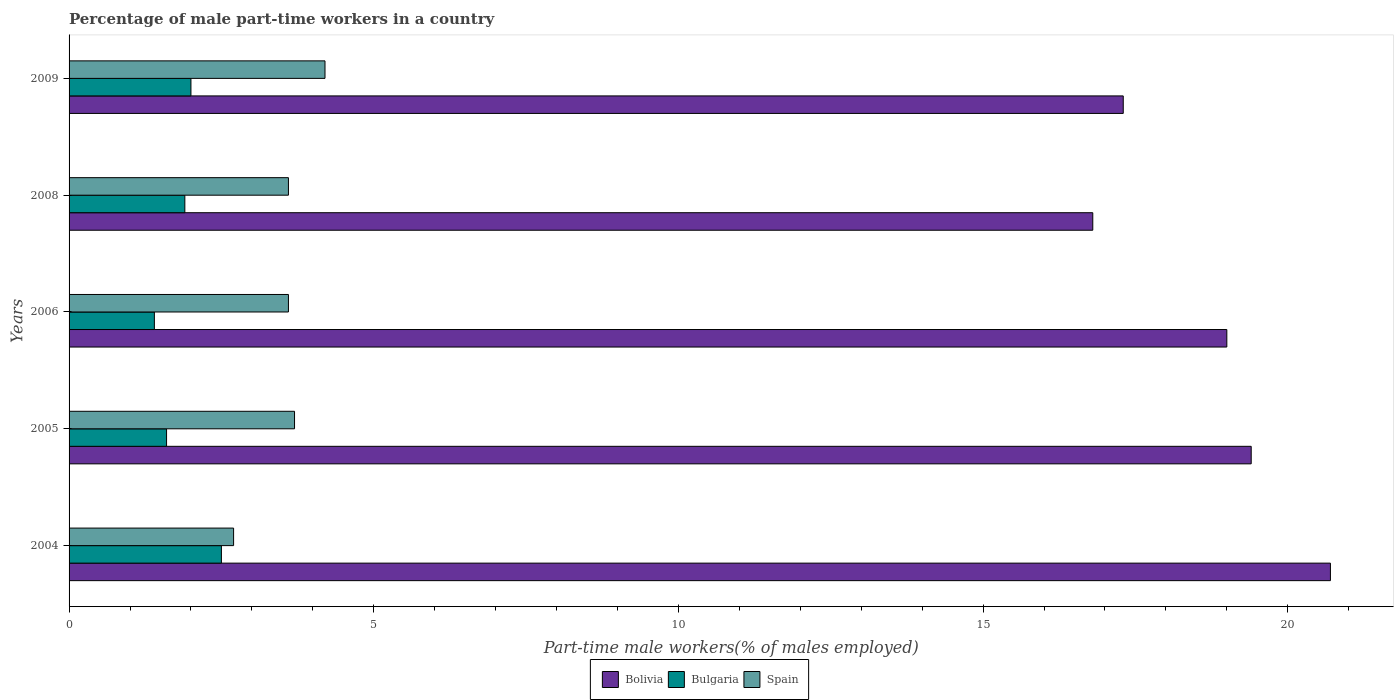How many different coloured bars are there?
Ensure brevity in your answer.  3. Are the number of bars on each tick of the Y-axis equal?
Provide a succinct answer. Yes. How many bars are there on the 1st tick from the bottom?
Your answer should be very brief. 3. In how many cases, is the number of bars for a given year not equal to the number of legend labels?
Ensure brevity in your answer.  0. What is the percentage of male part-time workers in Bulgaria in 2005?
Your answer should be very brief. 1.6. Across all years, what is the maximum percentage of male part-time workers in Spain?
Your response must be concise. 4.2. Across all years, what is the minimum percentage of male part-time workers in Spain?
Provide a short and direct response. 2.7. What is the total percentage of male part-time workers in Bolivia in the graph?
Ensure brevity in your answer.  93.2. What is the difference between the percentage of male part-time workers in Bulgaria in 2006 and that in 2009?
Give a very brief answer. -0.6. What is the difference between the percentage of male part-time workers in Bulgaria in 2006 and the percentage of male part-time workers in Spain in 2009?
Ensure brevity in your answer.  -2.8. What is the average percentage of male part-time workers in Bulgaria per year?
Offer a very short reply. 1.88. In the year 2009, what is the difference between the percentage of male part-time workers in Bolivia and percentage of male part-time workers in Spain?
Make the answer very short. 13.1. What is the ratio of the percentage of male part-time workers in Bolivia in 2004 to that in 2006?
Your answer should be compact. 1.09. Is the percentage of male part-time workers in Bolivia in 2006 less than that in 2009?
Offer a terse response. No. What is the difference between the highest and the lowest percentage of male part-time workers in Bulgaria?
Provide a short and direct response. 1.1. Are all the bars in the graph horizontal?
Offer a very short reply. Yes. How many legend labels are there?
Your response must be concise. 3. How are the legend labels stacked?
Provide a succinct answer. Horizontal. What is the title of the graph?
Provide a short and direct response. Percentage of male part-time workers in a country. What is the label or title of the X-axis?
Ensure brevity in your answer.  Part-time male workers(% of males employed). What is the Part-time male workers(% of males employed) of Bolivia in 2004?
Keep it short and to the point. 20.7. What is the Part-time male workers(% of males employed) in Spain in 2004?
Offer a very short reply. 2.7. What is the Part-time male workers(% of males employed) in Bolivia in 2005?
Your answer should be very brief. 19.4. What is the Part-time male workers(% of males employed) of Bulgaria in 2005?
Make the answer very short. 1.6. What is the Part-time male workers(% of males employed) in Spain in 2005?
Offer a very short reply. 3.7. What is the Part-time male workers(% of males employed) of Bulgaria in 2006?
Your answer should be compact. 1.4. What is the Part-time male workers(% of males employed) of Spain in 2006?
Make the answer very short. 3.6. What is the Part-time male workers(% of males employed) of Bolivia in 2008?
Give a very brief answer. 16.8. What is the Part-time male workers(% of males employed) of Bulgaria in 2008?
Your response must be concise. 1.9. What is the Part-time male workers(% of males employed) in Spain in 2008?
Your answer should be compact. 3.6. What is the Part-time male workers(% of males employed) of Bolivia in 2009?
Your answer should be compact. 17.3. What is the Part-time male workers(% of males employed) in Bulgaria in 2009?
Your answer should be very brief. 2. What is the Part-time male workers(% of males employed) of Spain in 2009?
Keep it short and to the point. 4.2. Across all years, what is the maximum Part-time male workers(% of males employed) of Bolivia?
Provide a short and direct response. 20.7. Across all years, what is the maximum Part-time male workers(% of males employed) in Bulgaria?
Offer a very short reply. 2.5. Across all years, what is the maximum Part-time male workers(% of males employed) of Spain?
Keep it short and to the point. 4.2. Across all years, what is the minimum Part-time male workers(% of males employed) in Bolivia?
Ensure brevity in your answer.  16.8. Across all years, what is the minimum Part-time male workers(% of males employed) of Bulgaria?
Provide a short and direct response. 1.4. Across all years, what is the minimum Part-time male workers(% of males employed) in Spain?
Make the answer very short. 2.7. What is the total Part-time male workers(% of males employed) of Bolivia in the graph?
Your answer should be very brief. 93.2. What is the total Part-time male workers(% of males employed) in Bulgaria in the graph?
Your answer should be compact. 9.4. What is the difference between the Part-time male workers(% of males employed) in Bolivia in 2004 and that in 2005?
Your answer should be very brief. 1.3. What is the difference between the Part-time male workers(% of males employed) of Bolivia in 2004 and that in 2006?
Make the answer very short. 1.7. What is the difference between the Part-time male workers(% of males employed) in Bulgaria in 2004 and that in 2006?
Ensure brevity in your answer.  1.1. What is the difference between the Part-time male workers(% of males employed) of Spain in 2004 and that in 2006?
Your answer should be very brief. -0.9. What is the difference between the Part-time male workers(% of males employed) in Spain in 2004 and that in 2008?
Ensure brevity in your answer.  -0.9. What is the difference between the Part-time male workers(% of males employed) of Bolivia in 2004 and that in 2009?
Your response must be concise. 3.4. What is the difference between the Part-time male workers(% of males employed) of Bulgaria in 2004 and that in 2009?
Your answer should be very brief. 0.5. What is the difference between the Part-time male workers(% of males employed) of Spain in 2004 and that in 2009?
Your answer should be very brief. -1.5. What is the difference between the Part-time male workers(% of males employed) in Bulgaria in 2005 and that in 2006?
Provide a succinct answer. 0.2. What is the difference between the Part-time male workers(% of males employed) in Spain in 2005 and that in 2008?
Ensure brevity in your answer.  0.1. What is the difference between the Part-time male workers(% of males employed) of Bolivia in 2006 and that in 2009?
Offer a terse response. 1.7. What is the difference between the Part-time male workers(% of males employed) of Bolivia in 2008 and that in 2009?
Ensure brevity in your answer.  -0.5. What is the difference between the Part-time male workers(% of males employed) of Bulgaria in 2008 and that in 2009?
Ensure brevity in your answer.  -0.1. What is the difference between the Part-time male workers(% of males employed) of Bolivia in 2004 and the Part-time male workers(% of males employed) of Bulgaria in 2005?
Your response must be concise. 19.1. What is the difference between the Part-time male workers(% of males employed) of Bolivia in 2004 and the Part-time male workers(% of males employed) of Spain in 2005?
Make the answer very short. 17. What is the difference between the Part-time male workers(% of males employed) in Bolivia in 2004 and the Part-time male workers(% of males employed) in Bulgaria in 2006?
Your answer should be very brief. 19.3. What is the difference between the Part-time male workers(% of males employed) in Bolivia in 2004 and the Part-time male workers(% of males employed) in Spain in 2006?
Your answer should be very brief. 17.1. What is the difference between the Part-time male workers(% of males employed) of Bulgaria in 2004 and the Part-time male workers(% of males employed) of Spain in 2006?
Offer a terse response. -1.1. What is the difference between the Part-time male workers(% of males employed) in Bolivia in 2004 and the Part-time male workers(% of males employed) in Bulgaria in 2008?
Make the answer very short. 18.8. What is the difference between the Part-time male workers(% of males employed) in Bulgaria in 2004 and the Part-time male workers(% of males employed) in Spain in 2008?
Ensure brevity in your answer.  -1.1. What is the difference between the Part-time male workers(% of males employed) in Bolivia in 2004 and the Part-time male workers(% of males employed) in Bulgaria in 2009?
Keep it short and to the point. 18.7. What is the difference between the Part-time male workers(% of males employed) in Bolivia in 2004 and the Part-time male workers(% of males employed) in Spain in 2009?
Your answer should be very brief. 16.5. What is the difference between the Part-time male workers(% of males employed) of Bolivia in 2005 and the Part-time male workers(% of males employed) of Bulgaria in 2006?
Your response must be concise. 18. What is the difference between the Part-time male workers(% of males employed) in Bulgaria in 2005 and the Part-time male workers(% of males employed) in Spain in 2006?
Your response must be concise. -2. What is the difference between the Part-time male workers(% of males employed) of Bolivia in 2005 and the Part-time male workers(% of males employed) of Bulgaria in 2008?
Your answer should be compact. 17.5. What is the difference between the Part-time male workers(% of males employed) in Bolivia in 2005 and the Part-time male workers(% of males employed) in Bulgaria in 2009?
Provide a short and direct response. 17.4. What is the difference between the Part-time male workers(% of males employed) in Bolivia in 2006 and the Part-time male workers(% of males employed) in Bulgaria in 2008?
Ensure brevity in your answer.  17.1. What is the difference between the Part-time male workers(% of males employed) of Bulgaria in 2006 and the Part-time male workers(% of males employed) of Spain in 2008?
Your answer should be very brief. -2.2. What is the difference between the Part-time male workers(% of males employed) of Bolivia in 2006 and the Part-time male workers(% of males employed) of Spain in 2009?
Make the answer very short. 14.8. What is the difference between the Part-time male workers(% of males employed) of Bolivia in 2008 and the Part-time male workers(% of males employed) of Spain in 2009?
Your answer should be compact. 12.6. What is the average Part-time male workers(% of males employed) in Bolivia per year?
Provide a succinct answer. 18.64. What is the average Part-time male workers(% of males employed) of Bulgaria per year?
Provide a succinct answer. 1.88. What is the average Part-time male workers(% of males employed) of Spain per year?
Your response must be concise. 3.56. In the year 2004, what is the difference between the Part-time male workers(% of males employed) of Bolivia and Part-time male workers(% of males employed) of Bulgaria?
Provide a short and direct response. 18.2. In the year 2004, what is the difference between the Part-time male workers(% of males employed) in Bulgaria and Part-time male workers(% of males employed) in Spain?
Provide a succinct answer. -0.2. In the year 2005, what is the difference between the Part-time male workers(% of males employed) of Bolivia and Part-time male workers(% of males employed) of Spain?
Offer a terse response. 15.7. In the year 2006, what is the difference between the Part-time male workers(% of males employed) of Bulgaria and Part-time male workers(% of males employed) of Spain?
Your answer should be very brief. -2.2. In the year 2008, what is the difference between the Part-time male workers(% of males employed) in Bulgaria and Part-time male workers(% of males employed) in Spain?
Give a very brief answer. -1.7. In the year 2009, what is the difference between the Part-time male workers(% of males employed) of Bolivia and Part-time male workers(% of males employed) of Bulgaria?
Keep it short and to the point. 15.3. In the year 2009, what is the difference between the Part-time male workers(% of males employed) in Bolivia and Part-time male workers(% of males employed) in Spain?
Your answer should be compact. 13.1. In the year 2009, what is the difference between the Part-time male workers(% of males employed) of Bulgaria and Part-time male workers(% of males employed) of Spain?
Your answer should be very brief. -2.2. What is the ratio of the Part-time male workers(% of males employed) in Bolivia in 2004 to that in 2005?
Offer a terse response. 1.07. What is the ratio of the Part-time male workers(% of males employed) of Bulgaria in 2004 to that in 2005?
Provide a succinct answer. 1.56. What is the ratio of the Part-time male workers(% of males employed) of Spain in 2004 to that in 2005?
Ensure brevity in your answer.  0.73. What is the ratio of the Part-time male workers(% of males employed) in Bolivia in 2004 to that in 2006?
Provide a short and direct response. 1.09. What is the ratio of the Part-time male workers(% of males employed) of Bulgaria in 2004 to that in 2006?
Your response must be concise. 1.79. What is the ratio of the Part-time male workers(% of males employed) of Spain in 2004 to that in 2006?
Make the answer very short. 0.75. What is the ratio of the Part-time male workers(% of males employed) of Bolivia in 2004 to that in 2008?
Offer a very short reply. 1.23. What is the ratio of the Part-time male workers(% of males employed) in Bulgaria in 2004 to that in 2008?
Offer a very short reply. 1.32. What is the ratio of the Part-time male workers(% of males employed) in Bolivia in 2004 to that in 2009?
Provide a short and direct response. 1.2. What is the ratio of the Part-time male workers(% of males employed) of Bulgaria in 2004 to that in 2009?
Provide a short and direct response. 1.25. What is the ratio of the Part-time male workers(% of males employed) of Spain in 2004 to that in 2009?
Offer a very short reply. 0.64. What is the ratio of the Part-time male workers(% of males employed) in Bolivia in 2005 to that in 2006?
Provide a succinct answer. 1.02. What is the ratio of the Part-time male workers(% of males employed) of Bulgaria in 2005 to that in 2006?
Give a very brief answer. 1.14. What is the ratio of the Part-time male workers(% of males employed) in Spain in 2005 to that in 2006?
Keep it short and to the point. 1.03. What is the ratio of the Part-time male workers(% of males employed) of Bolivia in 2005 to that in 2008?
Provide a succinct answer. 1.15. What is the ratio of the Part-time male workers(% of males employed) of Bulgaria in 2005 to that in 2008?
Offer a terse response. 0.84. What is the ratio of the Part-time male workers(% of males employed) of Spain in 2005 to that in 2008?
Your answer should be very brief. 1.03. What is the ratio of the Part-time male workers(% of males employed) in Bolivia in 2005 to that in 2009?
Your answer should be compact. 1.12. What is the ratio of the Part-time male workers(% of males employed) in Spain in 2005 to that in 2009?
Ensure brevity in your answer.  0.88. What is the ratio of the Part-time male workers(% of males employed) in Bolivia in 2006 to that in 2008?
Ensure brevity in your answer.  1.13. What is the ratio of the Part-time male workers(% of males employed) in Bulgaria in 2006 to that in 2008?
Your answer should be very brief. 0.74. What is the ratio of the Part-time male workers(% of males employed) of Spain in 2006 to that in 2008?
Offer a terse response. 1. What is the ratio of the Part-time male workers(% of males employed) of Bolivia in 2006 to that in 2009?
Keep it short and to the point. 1.1. What is the ratio of the Part-time male workers(% of males employed) in Bulgaria in 2006 to that in 2009?
Your answer should be compact. 0.7. What is the ratio of the Part-time male workers(% of males employed) of Spain in 2006 to that in 2009?
Your answer should be very brief. 0.86. What is the ratio of the Part-time male workers(% of males employed) of Bolivia in 2008 to that in 2009?
Provide a succinct answer. 0.97. What is the difference between the highest and the second highest Part-time male workers(% of males employed) of Bulgaria?
Provide a succinct answer. 0.5. What is the difference between the highest and the second highest Part-time male workers(% of males employed) of Spain?
Provide a short and direct response. 0.5. What is the difference between the highest and the lowest Part-time male workers(% of males employed) in Bolivia?
Give a very brief answer. 3.9. What is the difference between the highest and the lowest Part-time male workers(% of males employed) in Bulgaria?
Provide a succinct answer. 1.1. 